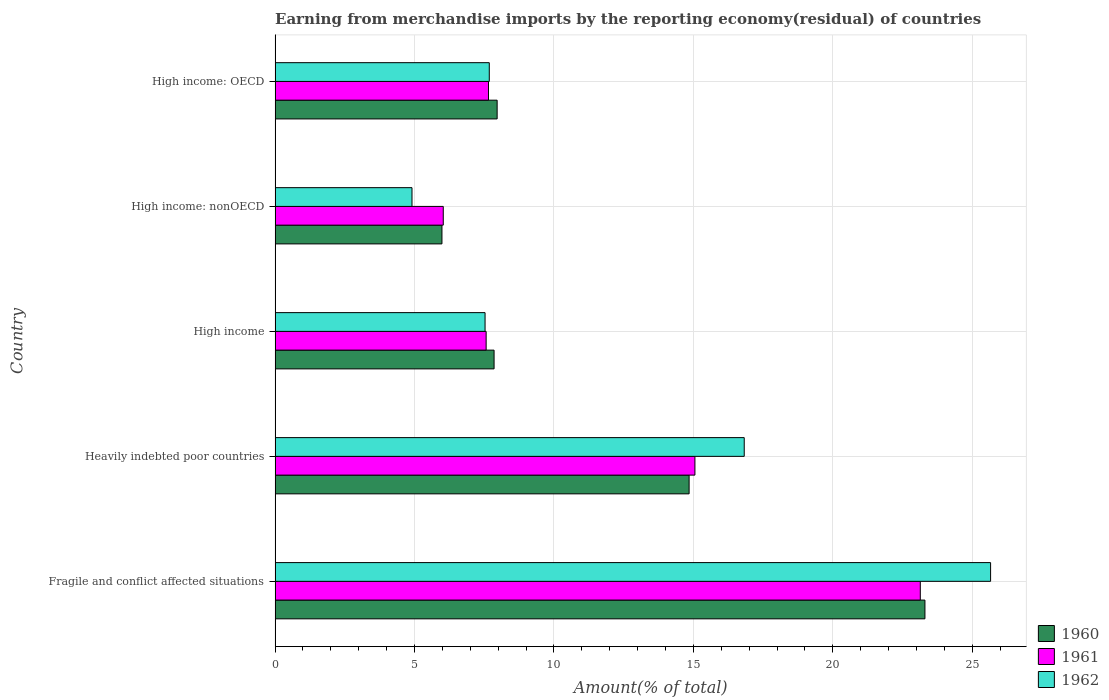How many groups of bars are there?
Give a very brief answer. 5. Are the number of bars on each tick of the Y-axis equal?
Offer a terse response. Yes. How many bars are there on the 2nd tick from the top?
Your answer should be very brief. 3. How many bars are there on the 4th tick from the bottom?
Your answer should be compact. 3. What is the label of the 5th group of bars from the top?
Provide a short and direct response. Fragile and conflict affected situations. In how many cases, is the number of bars for a given country not equal to the number of legend labels?
Give a very brief answer. 0. What is the percentage of amount earned from merchandise imports in 1961 in High income: OECD?
Your response must be concise. 7.65. Across all countries, what is the maximum percentage of amount earned from merchandise imports in 1961?
Give a very brief answer. 23.14. Across all countries, what is the minimum percentage of amount earned from merchandise imports in 1960?
Offer a very short reply. 5.98. In which country was the percentage of amount earned from merchandise imports in 1961 maximum?
Ensure brevity in your answer.  Fragile and conflict affected situations. In which country was the percentage of amount earned from merchandise imports in 1961 minimum?
Make the answer very short. High income: nonOECD. What is the total percentage of amount earned from merchandise imports in 1961 in the graph?
Keep it short and to the point. 59.44. What is the difference between the percentage of amount earned from merchandise imports in 1960 in Heavily indebted poor countries and that in High income: OECD?
Your answer should be compact. 6.88. What is the difference between the percentage of amount earned from merchandise imports in 1961 in High income and the percentage of amount earned from merchandise imports in 1962 in Fragile and conflict affected situations?
Make the answer very short. -18.09. What is the average percentage of amount earned from merchandise imports in 1961 per country?
Ensure brevity in your answer.  11.89. What is the difference between the percentage of amount earned from merchandise imports in 1960 and percentage of amount earned from merchandise imports in 1962 in Fragile and conflict affected situations?
Make the answer very short. -2.35. In how many countries, is the percentage of amount earned from merchandise imports in 1960 greater than 15 %?
Keep it short and to the point. 1. What is the ratio of the percentage of amount earned from merchandise imports in 1962 in Heavily indebted poor countries to that in High income: nonOECD?
Your response must be concise. 3.43. Is the difference between the percentage of amount earned from merchandise imports in 1960 in High income: OECD and High income: nonOECD greater than the difference between the percentage of amount earned from merchandise imports in 1962 in High income: OECD and High income: nonOECD?
Your answer should be compact. No. What is the difference between the highest and the second highest percentage of amount earned from merchandise imports in 1961?
Offer a terse response. 8.08. What is the difference between the highest and the lowest percentage of amount earned from merchandise imports in 1960?
Provide a short and direct response. 17.32. In how many countries, is the percentage of amount earned from merchandise imports in 1960 greater than the average percentage of amount earned from merchandise imports in 1960 taken over all countries?
Ensure brevity in your answer.  2. Is the sum of the percentage of amount earned from merchandise imports in 1960 in High income and High income: nonOECD greater than the maximum percentage of amount earned from merchandise imports in 1961 across all countries?
Ensure brevity in your answer.  No. What does the 2nd bar from the top in Fragile and conflict affected situations represents?
Offer a terse response. 1961. Is it the case that in every country, the sum of the percentage of amount earned from merchandise imports in 1961 and percentage of amount earned from merchandise imports in 1960 is greater than the percentage of amount earned from merchandise imports in 1962?
Offer a terse response. Yes. How many bars are there?
Provide a short and direct response. 15. How many countries are there in the graph?
Keep it short and to the point. 5. Are the values on the major ticks of X-axis written in scientific E-notation?
Your answer should be very brief. No. Does the graph contain any zero values?
Make the answer very short. No. Does the graph contain grids?
Make the answer very short. Yes. How many legend labels are there?
Keep it short and to the point. 3. How are the legend labels stacked?
Make the answer very short. Vertical. What is the title of the graph?
Your answer should be compact. Earning from merchandise imports by the reporting economy(residual) of countries. What is the label or title of the X-axis?
Make the answer very short. Amount(% of total). What is the Amount(% of total) of 1960 in Fragile and conflict affected situations?
Ensure brevity in your answer.  23.3. What is the Amount(% of total) in 1961 in Fragile and conflict affected situations?
Offer a terse response. 23.14. What is the Amount(% of total) of 1962 in Fragile and conflict affected situations?
Offer a very short reply. 25.66. What is the Amount(% of total) of 1960 in Heavily indebted poor countries?
Provide a succinct answer. 14.85. What is the Amount(% of total) in 1961 in Heavily indebted poor countries?
Keep it short and to the point. 15.05. What is the Amount(% of total) in 1962 in Heavily indebted poor countries?
Your response must be concise. 16.82. What is the Amount(% of total) in 1960 in High income?
Keep it short and to the point. 7.85. What is the Amount(% of total) of 1961 in High income?
Give a very brief answer. 7.57. What is the Amount(% of total) in 1962 in High income?
Keep it short and to the point. 7.53. What is the Amount(% of total) of 1960 in High income: nonOECD?
Your response must be concise. 5.98. What is the Amount(% of total) in 1961 in High income: nonOECD?
Give a very brief answer. 6.03. What is the Amount(% of total) of 1962 in High income: nonOECD?
Provide a short and direct response. 4.91. What is the Amount(% of total) in 1960 in High income: OECD?
Keep it short and to the point. 7.96. What is the Amount(% of total) of 1961 in High income: OECD?
Provide a succinct answer. 7.65. What is the Amount(% of total) of 1962 in High income: OECD?
Ensure brevity in your answer.  7.68. Across all countries, what is the maximum Amount(% of total) in 1960?
Give a very brief answer. 23.3. Across all countries, what is the maximum Amount(% of total) of 1961?
Make the answer very short. 23.14. Across all countries, what is the maximum Amount(% of total) in 1962?
Your answer should be compact. 25.66. Across all countries, what is the minimum Amount(% of total) of 1960?
Your response must be concise. 5.98. Across all countries, what is the minimum Amount(% of total) of 1961?
Make the answer very short. 6.03. Across all countries, what is the minimum Amount(% of total) in 1962?
Provide a succinct answer. 4.91. What is the total Amount(% of total) in 1960 in the graph?
Offer a terse response. 59.95. What is the total Amount(% of total) of 1961 in the graph?
Ensure brevity in your answer.  59.44. What is the total Amount(% of total) of 1962 in the graph?
Offer a very short reply. 62.6. What is the difference between the Amount(% of total) of 1960 in Fragile and conflict affected situations and that in Heavily indebted poor countries?
Keep it short and to the point. 8.46. What is the difference between the Amount(% of total) in 1961 in Fragile and conflict affected situations and that in Heavily indebted poor countries?
Ensure brevity in your answer.  8.08. What is the difference between the Amount(% of total) of 1962 in Fragile and conflict affected situations and that in Heavily indebted poor countries?
Give a very brief answer. 8.83. What is the difference between the Amount(% of total) of 1960 in Fragile and conflict affected situations and that in High income?
Keep it short and to the point. 15.45. What is the difference between the Amount(% of total) in 1961 in Fragile and conflict affected situations and that in High income?
Keep it short and to the point. 15.57. What is the difference between the Amount(% of total) in 1962 in Fragile and conflict affected situations and that in High income?
Your answer should be compact. 18.13. What is the difference between the Amount(% of total) of 1960 in Fragile and conflict affected situations and that in High income: nonOECD?
Give a very brief answer. 17.32. What is the difference between the Amount(% of total) of 1961 in Fragile and conflict affected situations and that in High income: nonOECD?
Your answer should be compact. 17.11. What is the difference between the Amount(% of total) of 1962 in Fragile and conflict affected situations and that in High income: nonOECD?
Ensure brevity in your answer.  20.75. What is the difference between the Amount(% of total) in 1960 in Fragile and conflict affected situations and that in High income: OECD?
Offer a terse response. 15.34. What is the difference between the Amount(% of total) of 1961 in Fragile and conflict affected situations and that in High income: OECD?
Your response must be concise. 15.48. What is the difference between the Amount(% of total) in 1962 in Fragile and conflict affected situations and that in High income: OECD?
Your answer should be very brief. 17.98. What is the difference between the Amount(% of total) of 1960 in Heavily indebted poor countries and that in High income?
Your answer should be very brief. 6.99. What is the difference between the Amount(% of total) in 1961 in Heavily indebted poor countries and that in High income?
Ensure brevity in your answer.  7.49. What is the difference between the Amount(% of total) in 1962 in Heavily indebted poor countries and that in High income?
Your answer should be very brief. 9.29. What is the difference between the Amount(% of total) of 1960 in Heavily indebted poor countries and that in High income: nonOECD?
Make the answer very short. 8.86. What is the difference between the Amount(% of total) of 1961 in Heavily indebted poor countries and that in High income: nonOECD?
Provide a succinct answer. 9.02. What is the difference between the Amount(% of total) of 1962 in Heavily indebted poor countries and that in High income: nonOECD?
Your answer should be very brief. 11.91. What is the difference between the Amount(% of total) in 1960 in Heavily indebted poor countries and that in High income: OECD?
Your response must be concise. 6.88. What is the difference between the Amount(% of total) in 1961 in Heavily indebted poor countries and that in High income: OECD?
Provide a succinct answer. 7.4. What is the difference between the Amount(% of total) of 1962 in Heavily indebted poor countries and that in High income: OECD?
Your answer should be very brief. 9.14. What is the difference between the Amount(% of total) in 1960 in High income and that in High income: nonOECD?
Keep it short and to the point. 1.87. What is the difference between the Amount(% of total) in 1961 in High income and that in High income: nonOECD?
Your answer should be compact. 1.54. What is the difference between the Amount(% of total) in 1962 in High income and that in High income: nonOECD?
Ensure brevity in your answer.  2.62. What is the difference between the Amount(% of total) in 1960 in High income and that in High income: OECD?
Provide a short and direct response. -0.11. What is the difference between the Amount(% of total) in 1961 in High income and that in High income: OECD?
Keep it short and to the point. -0.08. What is the difference between the Amount(% of total) of 1962 in High income and that in High income: OECD?
Offer a terse response. -0.15. What is the difference between the Amount(% of total) in 1960 in High income: nonOECD and that in High income: OECD?
Make the answer very short. -1.98. What is the difference between the Amount(% of total) in 1961 in High income: nonOECD and that in High income: OECD?
Keep it short and to the point. -1.62. What is the difference between the Amount(% of total) in 1962 in High income: nonOECD and that in High income: OECD?
Your response must be concise. -2.77. What is the difference between the Amount(% of total) of 1960 in Fragile and conflict affected situations and the Amount(% of total) of 1961 in Heavily indebted poor countries?
Your response must be concise. 8.25. What is the difference between the Amount(% of total) of 1960 in Fragile and conflict affected situations and the Amount(% of total) of 1962 in Heavily indebted poor countries?
Give a very brief answer. 6.48. What is the difference between the Amount(% of total) of 1961 in Fragile and conflict affected situations and the Amount(% of total) of 1962 in Heavily indebted poor countries?
Make the answer very short. 6.31. What is the difference between the Amount(% of total) of 1960 in Fragile and conflict affected situations and the Amount(% of total) of 1961 in High income?
Make the answer very short. 15.73. What is the difference between the Amount(% of total) in 1960 in Fragile and conflict affected situations and the Amount(% of total) in 1962 in High income?
Offer a very short reply. 15.77. What is the difference between the Amount(% of total) in 1961 in Fragile and conflict affected situations and the Amount(% of total) in 1962 in High income?
Ensure brevity in your answer.  15.61. What is the difference between the Amount(% of total) in 1960 in Fragile and conflict affected situations and the Amount(% of total) in 1961 in High income: nonOECD?
Your answer should be compact. 17.27. What is the difference between the Amount(% of total) of 1960 in Fragile and conflict affected situations and the Amount(% of total) of 1962 in High income: nonOECD?
Provide a short and direct response. 18.39. What is the difference between the Amount(% of total) of 1961 in Fragile and conflict affected situations and the Amount(% of total) of 1962 in High income: nonOECD?
Your answer should be compact. 18.23. What is the difference between the Amount(% of total) in 1960 in Fragile and conflict affected situations and the Amount(% of total) in 1961 in High income: OECD?
Your answer should be very brief. 15.65. What is the difference between the Amount(% of total) in 1960 in Fragile and conflict affected situations and the Amount(% of total) in 1962 in High income: OECD?
Your answer should be compact. 15.62. What is the difference between the Amount(% of total) of 1961 in Fragile and conflict affected situations and the Amount(% of total) of 1962 in High income: OECD?
Make the answer very short. 15.46. What is the difference between the Amount(% of total) in 1960 in Heavily indebted poor countries and the Amount(% of total) in 1961 in High income?
Provide a succinct answer. 7.28. What is the difference between the Amount(% of total) in 1960 in Heavily indebted poor countries and the Amount(% of total) in 1962 in High income?
Give a very brief answer. 7.32. What is the difference between the Amount(% of total) of 1961 in Heavily indebted poor countries and the Amount(% of total) of 1962 in High income?
Ensure brevity in your answer.  7.52. What is the difference between the Amount(% of total) in 1960 in Heavily indebted poor countries and the Amount(% of total) in 1961 in High income: nonOECD?
Your response must be concise. 8.82. What is the difference between the Amount(% of total) in 1960 in Heavily indebted poor countries and the Amount(% of total) in 1962 in High income: nonOECD?
Your response must be concise. 9.94. What is the difference between the Amount(% of total) of 1961 in Heavily indebted poor countries and the Amount(% of total) of 1962 in High income: nonOECD?
Provide a short and direct response. 10.14. What is the difference between the Amount(% of total) of 1960 in Heavily indebted poor countries and the Amount(% of total) of 1961 in High income: OECD?
Provide a succinct answer. 7.19. What is the difference between the Amount(% of total) of 1960 in Heavily indebted poor countries and the Amount(% of total) of 1962 in High income: OECD?
Your answer should be compact. 7.17. What is the difference between the Amount(% of total) of 1961 in Heavily indebted poor countries and the Amount(% of total) of 1962 in High income: OECD?
Provide a short and direct response. 7.37. What is the difference between the Amount(% of total) in 1960 in High income and the Amount(% of total) in 1961 in High income: nonOECD?
Provide a succinct answer. 1.82. What is the difference between the Amount(% of total) in 1960 in High income and the Amount(% of total) in 1962 in High income: nonOECD?
Your answer should be compact. 2.94. What is the difference between the Amount(% of total) in 1961 in High income and the Amount(% of total) in 1962 in High income: nonOECD?
Your answer should be compact. 2.66. What is the difference between the Amount(% of total) in 1960 in High income and the Amount(% of total) in 1961 in High income: OECD?
Your answer should be very brief. 0.2. What is the difference between the Amount(% of total) of 1960 in High income and the Amount(% of total) of 1962 in High income: OECD?
Give a very brief answer. 0.17. What is the difference between the Amount(% of total) in 1961 in High income and the Amount(% of total) in 1962 in High income: OECD?
Ensure brevity in your answer.  -0.11. What is the difference between the Amount(% of total) of 1960 in High income: nonOECD and the Amount(% of total) of 1961 in High income: OECD?
Keep it short and to the point. -1.67. What is the difference between the Amount(% of total) in 1960 in High income: nonOECD and the Amount(% of total) in 1962 in High income: OECD?
Your answer should be very brief. -1.7. What is the difference between the Amount(% of total) in 1961 in High income: nonOECD and the Amount(% of total) in 1962 in High income: OECD?
Keep it short and to the point. -1.65. What is the average Amount(% of total) in 1960 per country?
Your answer should be very brief. 11.99. What is the average Amount(% of total) of 1961 per country?
Provide a succinct answer. 11.89. What is the average Amount(% of total) of 1962 per country?
Offer a very short reply. 12.52. What is the difference between the Amount(% of total) of 1960 and Amount(% of total) of 1961 in Fragile and conflict affected situations?
Offer a very short reply. 0.17. What is the difference between the Amount(% of total) of 1960 and Amount(% of total) of 1962 in Fragile and conflict affected situations?
Ensure brevity in your answer.  -2.35. What is the difference between the Amount(% of total) of 1961 and Amount(% of total) of 1962 in Fragile and conflict affected situations?
Give a very brief answer. -2.52. What is the difference between the Amount(% of total) in 1960 and Amount(% of total) in 1961 in Heavily indebted poor countries?
Give a very brief answer. -0.21. What is the difference between the Amount(% of total) in 1960 and Amount(% of total) in 1962 in Heavily indebted poor countries?
Your answer should be compact. -1.98. What is the difference between the Amount(% of total) of 1961 and Amount(% of total) of 1962 in Heavily indebted poor countries?
Provide a succinct answer. -1.77. What is the difference between the Amount(% of total) in 1960 and Amount(% of total) in 1961 in High income?
Keep it short and to the point. 0.28. What is the difference between the Amount(% of total) in 1960 and Amount(% of total) in 1962 in High income?
Ensure brevity in your answer.  0.32. What is the difference between the Amount(% of total) in 1961 and Amount(% of total) in 1962 in High income?
Offer a very short reply. 0.04. What is the difference between the Amount(% of total) in 1960 and Amount(% of total) in 1961 in High income: nonOECD?
Your answer should be very brief. -0.05. What is the difference between the Amount(% of total) of 1960 and Amount(% of total) of 1962 in High income: nonOECD?
Make the answer very short. 1.07. What is the difference between the Amount(% of total) of 1961 and Amount(% of total) of 1962 in High income: nonOECD?
Give a very brief answer. 1.12. What is the difference between the Amount(% of total) in 1960 and Amount(% of total) in 1961 in High income: OECD?
Provide a succinct answer. 0.31. What is the difference between the Amount(% of total) in 1960 and Amount(% of total) in 1962 in High income: OECD?
Provide a succinct answer. 0.28. What is the difference between the Amount(% of total) in 1961 and Amount(% of total) in 1962 in High income: OECD?
Provide a short and direct response. -0.03. What is the ratio of the Amount(% of total) of 1960 in Fragile and conflict affected situations to that in Heavily indebted poor countries?
Give a very brief answer. 1.57. What is the ratio of the Amount(% of total) in 1961 in Fragile and conflict affected situations to that in Heavily indebted poor countries?
Ensure brevity in your answer.  1.54. What is the ratio of the Amount(% of total) of 1962 in Fragile and conflict affected situations to that in Heavily indebted poor countries?
Make the answer very short. 1.53. What is the ratio of the Amount(% of total) in 1960 in Fragile and conflict affected situations to that in High income?
Your answer should be compact. 2.97. What is the ratio of the Amount(% of total) in 1961 in Fragile and conflict affected situations to that in High income?
Offer a very short reply. 3.06. What is the ratio of the Amount(% of total) in 1962 in Fragile and conflict affected situations to that in High income?
Ensure brevity in your answer.  3.41. What is the ratio of the Amount(% of total) in 1960 in Fragile and conflict affected situations to that in High income: nonOECD?
Keep it short and to the point. 3.89. What is the ratio of the Amount(% of total) of 1961 in Fragile and conflict affected situations to that in High income: nonOECD?
Provide a short and direct response. 3.84. What is the ratio of the Amount(% of total) in 1962 in Fragile and conflict affected situations to that in High income: nonOECD?
Your response must be concise. 5.23. What is the ratio of the Amount(% of total) in 1960 in Fragile and conflict affected situations to that in High income: OECD?
Provide a succinct answer. 2.93. What is the ratio of the Amount(% of total) in 1961 in Fragile and conflict affected situations to that in High income: OECD?
Give a very brief answer. 3.02. What is the ratio of the Amount(% of total) in 1962 in Fragile and conflict affected situations to that in High income: OECD?
Keep it short and to the point. 3.34. What is the ratio of the Amount(% of total) of 1960 in Heavily indebted poor countries to that in High income?
Ensure brevity in your answer.  1.89. What is the ratio of the Amount(% of total) in 1961 in Heavily indebted poor countries to that in High income?
Give a very brief answer. 1.99. What is the ratio of the Amount(% of total) in 1962 in Heavily indebted poor countries to that in High income?
Your answer should be very brief. 2.23. What is the ratio of the Amount(% of total) of 1960 in Heavily indebted poor countries to that in High income: nonOECD?
Provide a succinct answer. 2.48. What is the ratio of the Amount(% of total) in 1961 in Heavily indebted poor countries to that in High income: nonOECD?
Your response must be concise. 2.5. What is the ratio of the Amount(% of total) of 1962 in Heavily indebted poor countries to that in High income: nonOECD?
Your answer should be very brief. 3.43. What is the ratio of the Amount(% of total) of 1960 in Heavily indebted poor countries to that in High income: OECD?
Offer a terse response. 1.86. What is the ratio of the Amount(% of total) in 1961 in Heavily indebted poor countries to that in High income: OECD?
Your answer should be very brief. 1.97. What is the ratio of the Amount(% of total) in 1962 in Heavily indebted poor countries to that in High income: OECD?
Provide a succinct answer. 2.19. What is the ratio of the Amount(% of total) of 1960 in High income to that in High income: nonOECD?
Offer a terse response. 1.31. What is the ratio of the Amount(% of total) of 1961 in High income to that in High income: nonOECD?
Provide a succinct answer. 1.25. What is the ratio of the Amount(% of total) in 1962 in High income to that in High income: nonOECD?
Make the answer very short. 1.53. What is the ratio of the Amount(% of total) in 1960 in High income to that in High income: OECD?
Keep it short and to the point. 0.99. What is the ratio of the Amount(% of total) in 1961 in High income to that in High income: OECD?
Make the answer very short. 0.99. What is the ratio of the Amount(% of total) in 1962 in High income to that in High income: OECD?
Make the answer very short. 0.98. What is the ratio of the Amount(% of total) of 1960 in High income: nonOECD to that in High income: OECD?
Offer a terse response. 0.75. What is the ratio of the Amount(% of total) in 1961 in High income: nonOECD to that in High income: OECD?
Your answer should be very brief. 0.79. What is the ratio of the Amount(% of total) of 1962 in High income: nonOECD to that in High income: OECD?
Offer a terse response. 0.64. What is the difference between the highest and the second highest Amount(% of total) in 1960?
Your answer should be very brief. 8.46. What is the difference between the highest and the second highest Amount(% of total) in 1961?
Ensure brevity in your answer.  8.08. What is the difference between the highest and the second highest Amount(% of total) of 1962?
Provide a short and direct response. 8.83. What is the difference between the highest and the lowest Amount(% of total) of 1960?
Provide a short and direct response. 17.32. What is the difference between the highest and the lowest Amount(% of total) of 1961?
Your answer should be very brief. 17.11. What is the difference between the highest and the lowest Amount(% of total) of 1962?
Keep it short and to the point. 20.75. 